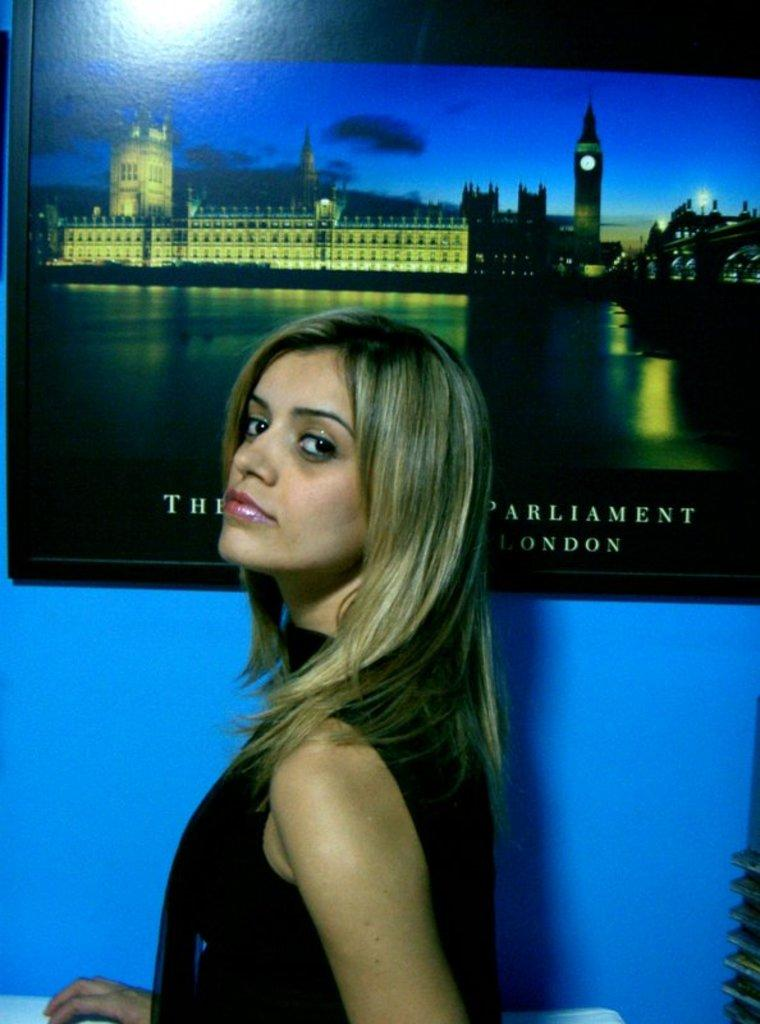Who is present in the image? There is a woman in the image. What is the background of the image? The image is on a blue wall. What type of structures can be seen in the image? There are buildings and a tower visible in the image. What part of the natural environment is visible in the image? The sky is visible in the image. Is there any text or writing in the image? Yes, there is something written on the picture. How is the woman trying to fix the trouble with the glue in the image? There is no mention of trouble or glue in the image; it features a woman, a blue wall, buildings, a tower, the sky, and something written on the picture. 